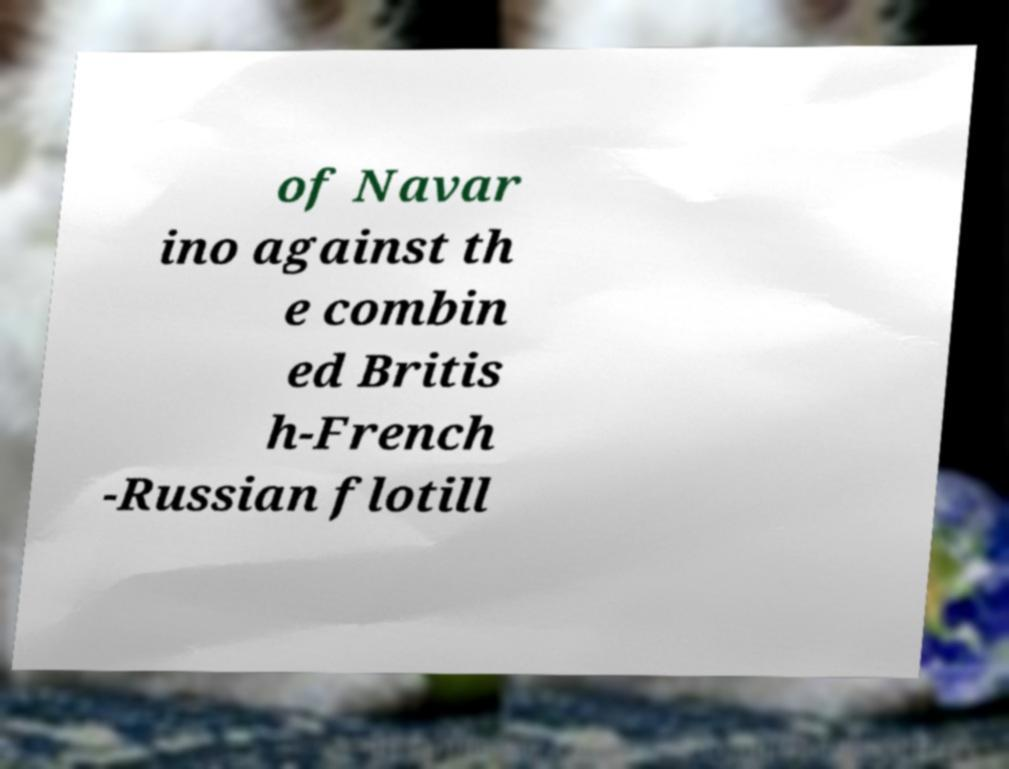Could you extract and type out the text from this image? of Navar ino against th e combin ed Britis h-French -Russian flotill 